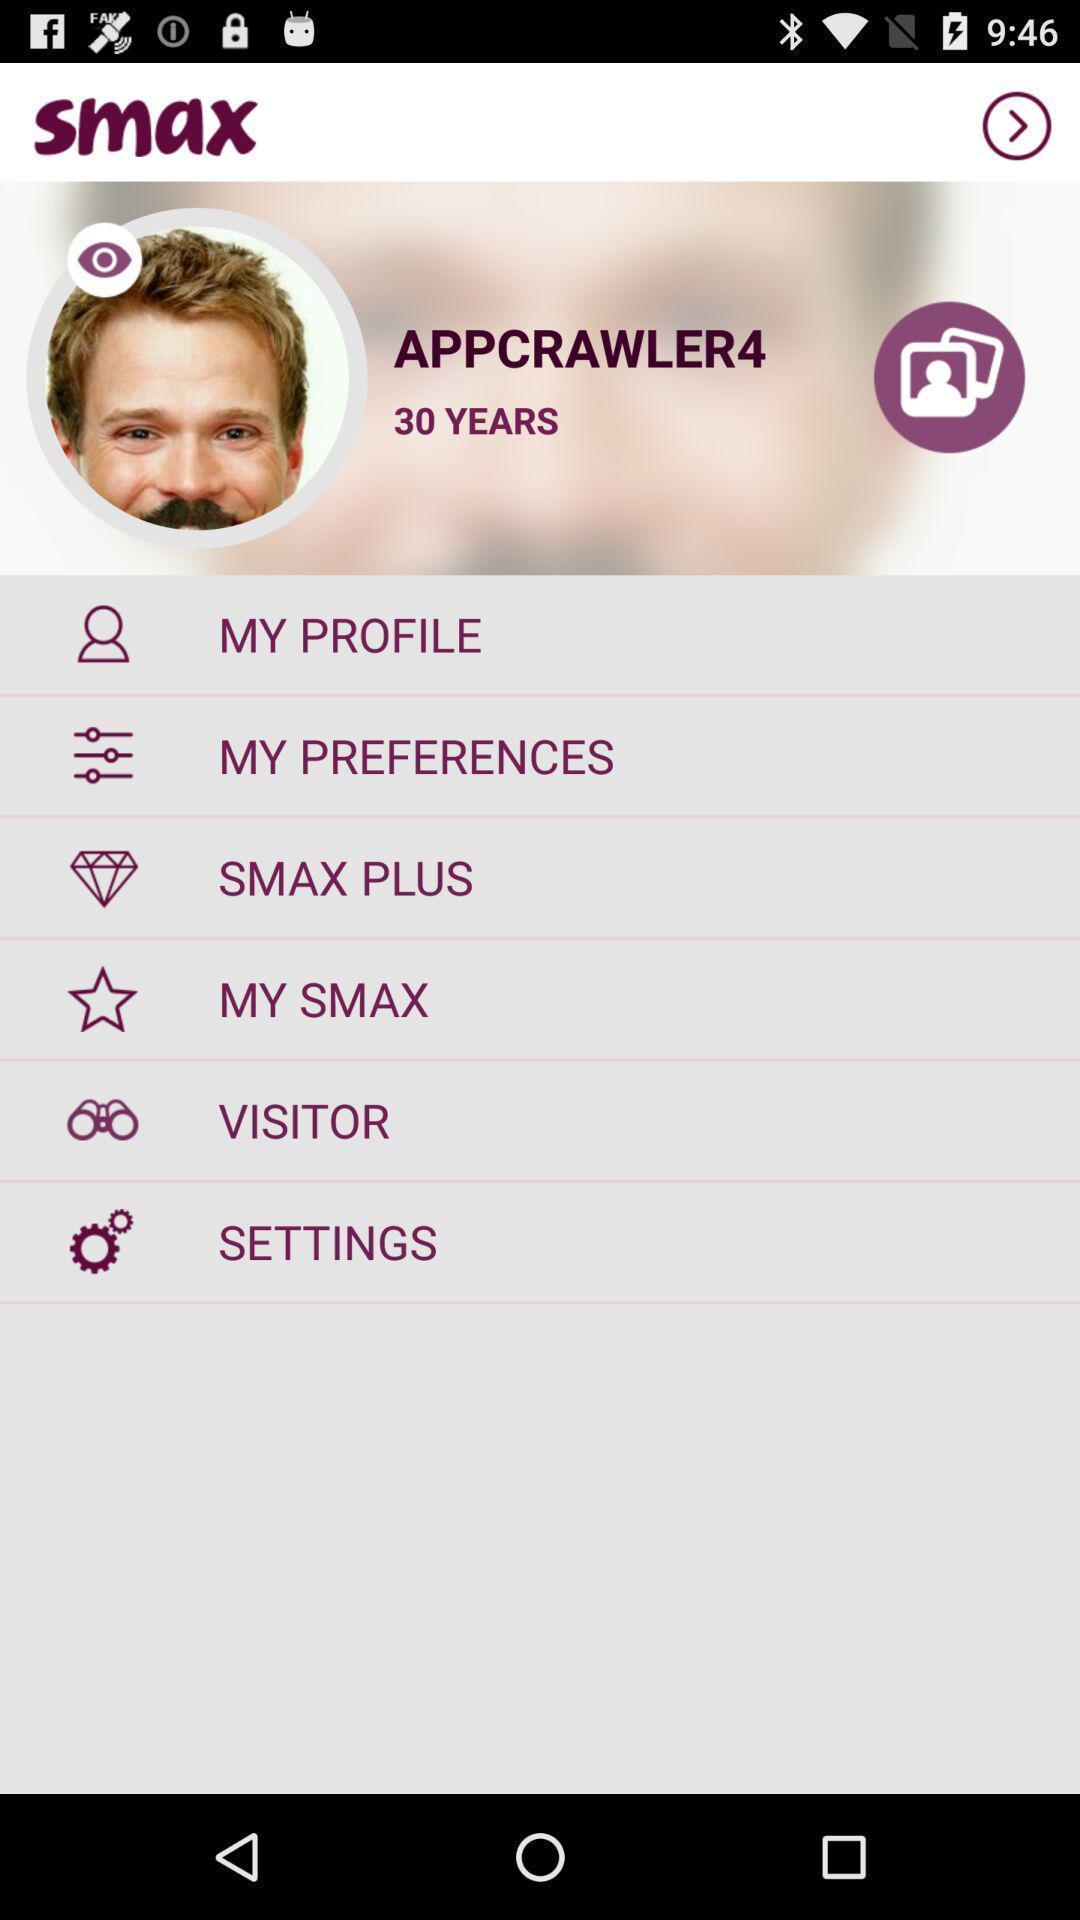What is the overall content of this screenshot? Screen displaying user information and other options. 